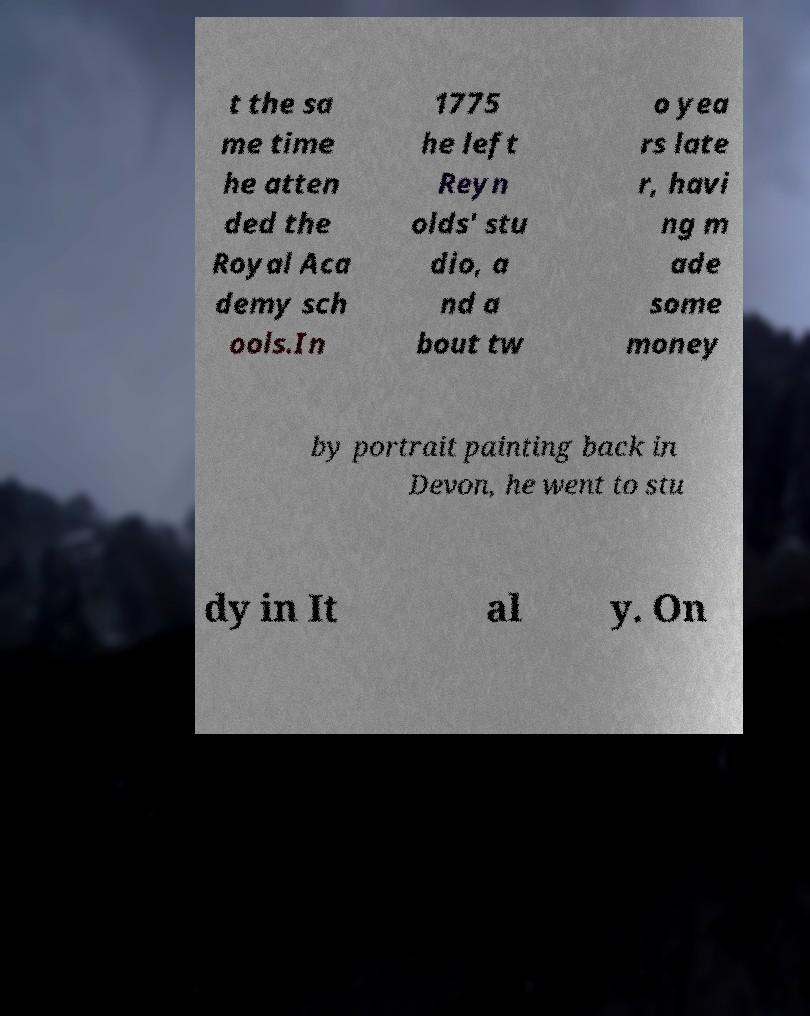I need the written content from this picture converted into text. Can you do that? t the sa me time he atten ded the Royal Aca demy sch ools.In 1775 he left Reyn olds' stu dio, a nd a bout tw o yea rs late r, havi ng m ade some money by portrait painting back in Devon, he went to stu dy in It al y. On 